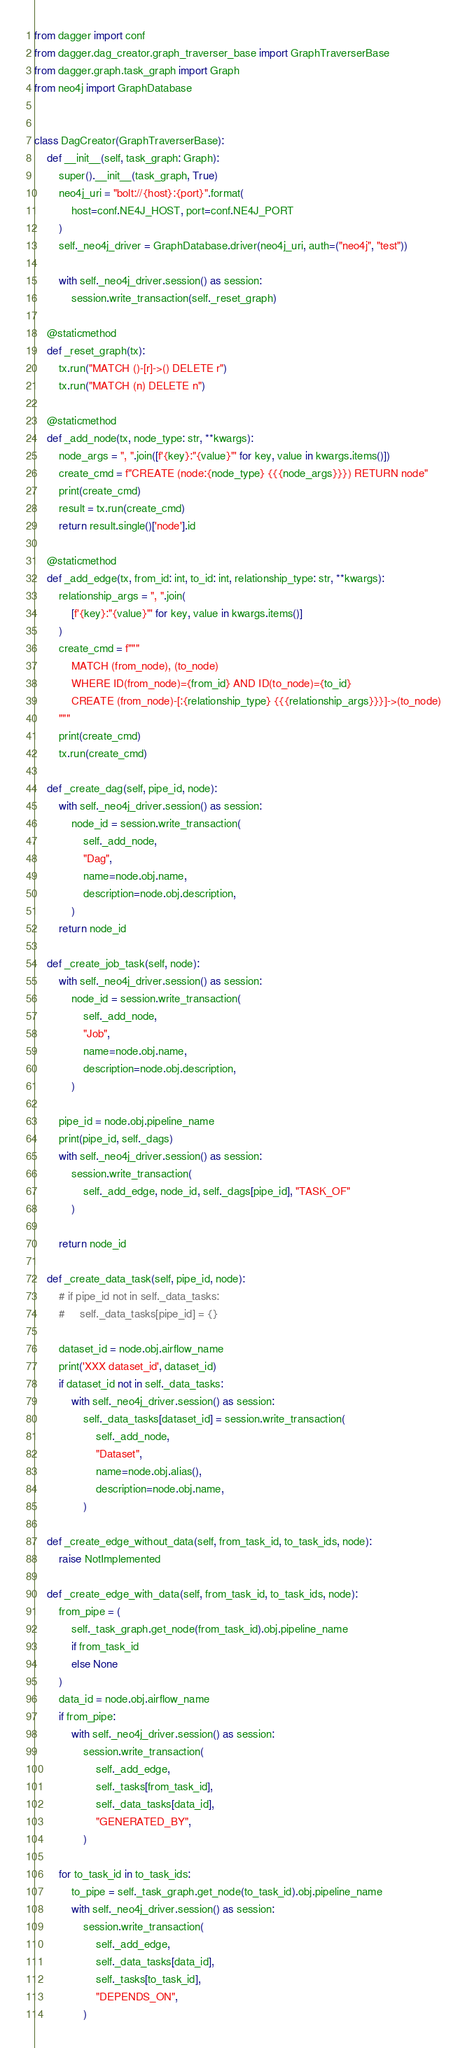Convert code to text. <code><loc_0><loc_0><loc_500><loc_500><_Python_>from dagger import conf
from dagger.dag_creator.graph_traverser_base import GraphTraverserBase
from dagger.graph.task_graph import Graph
from neo4j import GraphDatabase


class DagCreator(GraphTraverserBase):
    def __init__(self, task_graph: Graph):
        super().__init__(task_graph, True)
        neo4j_uri = "bolt://{host}:{port}".format(
            host=conf.NE4J_HOST, port=conf.NE4J_PORT
        )
        self._neo4j_driver = GraphDatabase.driver(neo4j_uri, auth=("neo4j", "test"))

        with self._neo4j_driver.session() as session:
            session.write_transaction(self._reset_graph)

    @staticmethod
    def _reset_graph(tx):
        tx.run("MATCH ()-[r]->() DELETE r")
        tx.run("MATCH (n) DELETE n")

    @staticmethod
    def _add_node(tx, node_type: str, **kwargs):
        node_args = ", ".join([f'{key}:"{value}"' for key, value in kwargs.items()])
        create_cmd = f"CREATE (node:{node_type} {{{node_args}}}) RETURN node"
        print(create_cmd)
        result = tx.run(create_cmd)
        return result.single()['node'].id

    @staticmethod
    def _add_edge(tx, from_id: int, to_id: int, relationship_type: str, **kwargs):
        relationship_args = ", ".join(
            [f'{key}:"{value}"' for key, value in kwargs.items()]
        )
        create_cmd = f"""
            MATCH (from_node), (to_node)
            WHERE ID(from_node)={from_id} AND ID(to_node)={to_id}
            CREATE (from_node)-[:{relationship_type} {{{relationship_args}}}]->(to_node)
        """
        print(create_cmd)
        tx.run(create_cmd)

    def _create_dag(self, pipe_id, node):
        with self._neo4j_driver.session() as session:
            node_id = session.write_transaction(
                self._add_node,
                "Dag",
                name=node.obj.name,
                description=node.obj.description,
            )
        return node_id

    def _create_job_task(self, node):
        with self._neo4j_driver.session() as session:
            node_id = session.write_transaction(
                self._add_node,
                "Job",
                name=node.obj.name,
                description=node.obj.description,
            )

        pipe_id = node.obj.pipeline_name
        print(pipe_id, self._dags)
        with self._neo4j_driver.session() as session:
            session.write_transaction(
                self._add_edge, node_id, self._dags[pipe_id], "TASK_OF"
            )

        return node_id

    def _create_data_task(self, pipe_id, node):
        # if pipe_id not in self._data_tasks:
        #     self._data_tasks[pipe_id] = {}

        dataset_id = node.obj.airflow_name
        print('XXX dataset_id', dataset_id)
        if dataset_id not in self._data_tasks:
            with self._neo4j_driver.session() as session:
                self._data_tasks[dataset_id] = session.write_transaction(
                    self._add_node,
                    "Dataset",
                    name=node.obj.alias(),
                    description=node.obj.name,
                )

    def _create_edge_without_data(self, from_task_id, to_task_ids, node):
        raise NotImplemented

    def _create_edge_with_data(self, from_task_id, to_task_ids, node):
        from_pipe = (
            self._task_graph.get_node(from_task_id).obj.pipeline_name
            if from_task_id
            else None
        )
        data_id = node.obj.airflow_name
        if from_pipe:
            with self._neo4j_driver.session() as session:
                session.write_transaction(
                    self._add_edge,
                    self._tasks[from_task_id],
                    self._data_tasks[data_id],
                    "GENERATED_BY",
                )

        for to_task_id in to_task_ids:
            to_pipe = self._task_graph.get_node(to_task_id).obj.pipeline_name
            with self._neo4j_driver.session() as session:
                session.write_transaction(
                    self._add_edge,
                    self._data_tasks[data_id],
                    self._tasks[to_task_id],
                    "DEPENDS_ON",
                )
</code> 